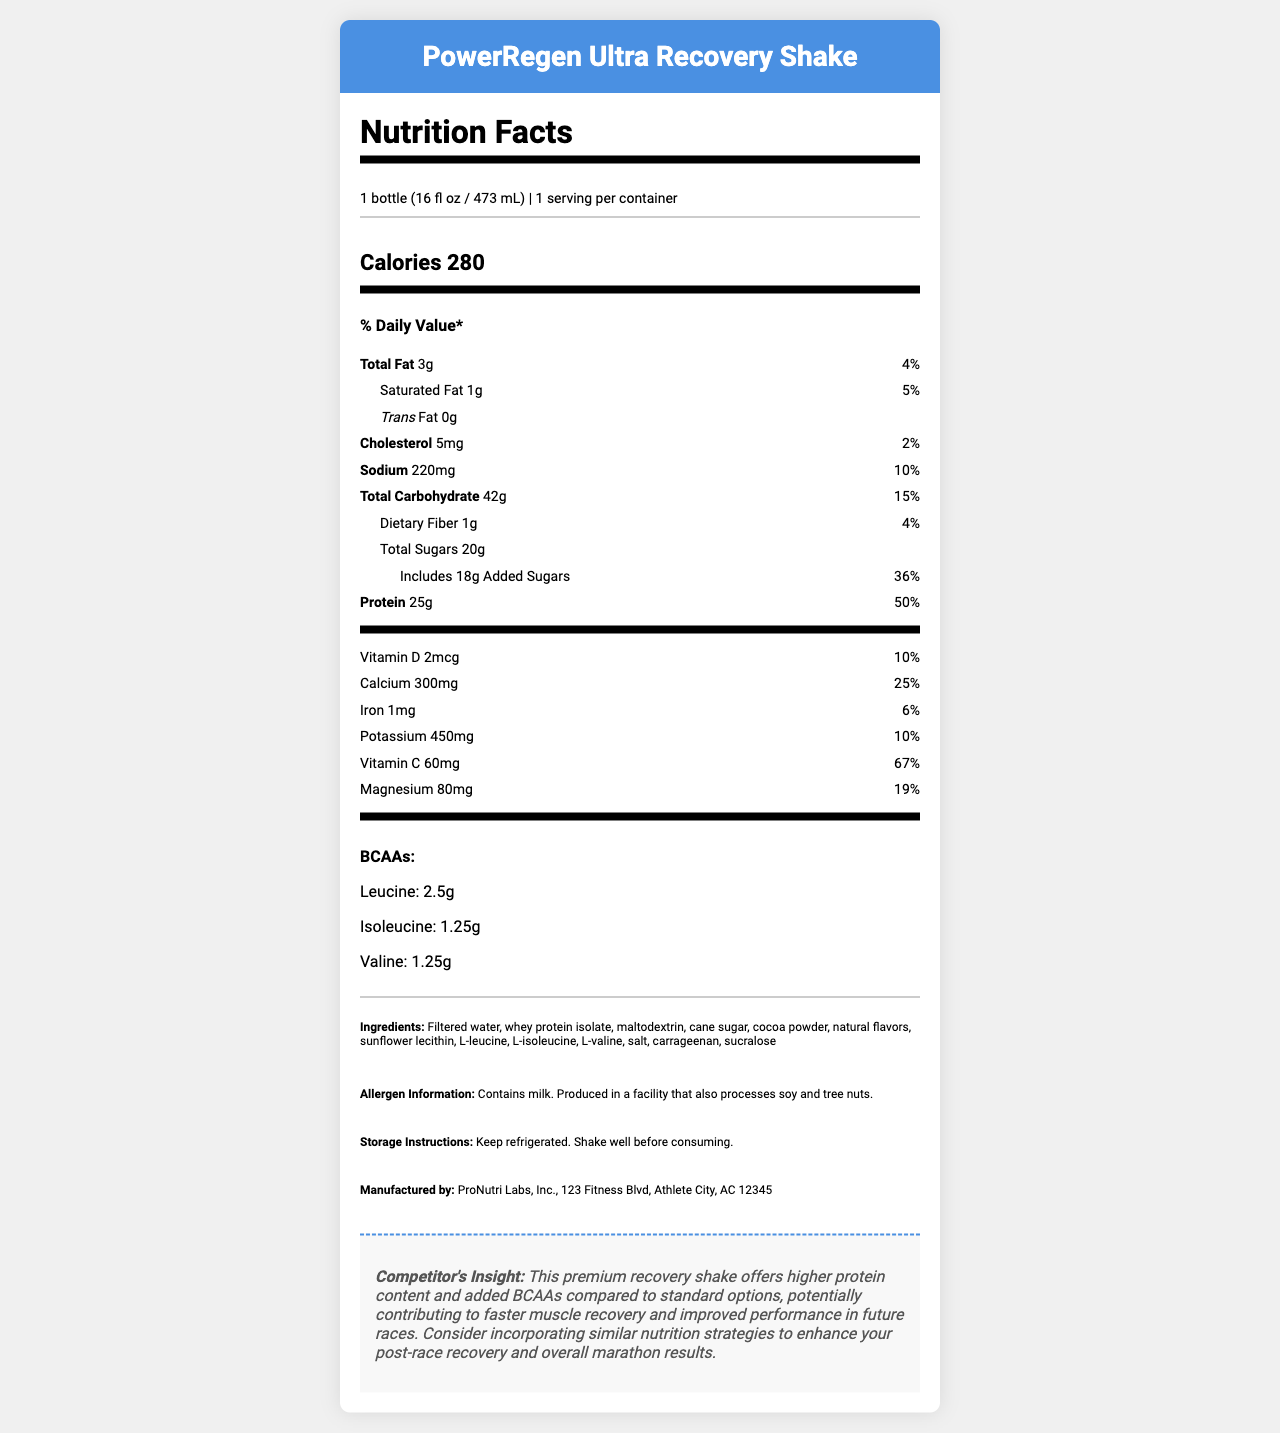what is the name of the product? The name of the product is stated at the top of the document in the header.
Answer: PowerRegen Ultra Recovery Shake what is the serving size of the protein shake? The serving size is listed under the serving information as "1 bottle (16 fl oz / 473 mL)".
Answer: 1 bottle (16 fl oz / 473 mL) how many calories are in one serving? The calorie content per serving is displayed prominently in the calorie information section as "Calories 280".
Answer: 280 calories what percentage of the daily value does the protein in this shake fulfill? The document specifies that the protein content of the shake provides 50% of the daily value.
Answer: 50% how much vitamin C does one serving contain? The vitamin content section lists the amount of vitamin C as 60mg.
Answer: 60mg what is the total carbohydrate content per serving? The total carbohydrate amount is displayed in the daily value section as "42g".
Answer: 42g how many grams of added sugars are in the shake? The document states "Includes 18g Added Sugars" and provides the daily value percentage as well.
Answer: 18g which of the following ingredients is not listed? A. Whey protein isolate B. Cocoa powder C. Soy protein isolate D. Cane sugar The ingredient list in the document does not include soy protein isolate, but it does contain whey protein isolate, cocoa powder, and cane sugar.
Answer: C. Soy protein isolate what is the manufacturer's name? A. PowerFitness Labs B. ProNutri Labs, Inc. C. Marathon Nutrition Co. The manufacturer information section lists ProNutri Labs, Inc. as the manufacturer.
Answer: B. ProNutri Labs, Inc. does the product contain any allergens? The allergen information specifies that the product contains milk and is produced in a facility that also processes soy and tree nuts.
Answer: Yes is this product intended to improve muscle recovery for athletes? The competitor insight clearly mentions that the shake is intended to contribute to faster muscle recovery and improved performance in future races.
Answer: Yes describe the main idea of the document. The document is divided into sections detailing the nutritional facts, ingredients, allergens, and additional insights about the product's benefits for athletic recovery.
Answer: The document provides detailed nutritional information about the PowerRegen Ultra Recovery Shake, highlighting its content of calories, macronutrients, vitamins, minerals, and BCAAs. It also lists ingredients, allergen information, storage instructions, and manufacturer details. The competitor insight suggests the shake's potential benefits for muscle recovery and performance improvement for athletes. what is the main benefit of BCAAs in this product? The document lists the amounts of BCAAs but does not elaborate on their specific benefits. The competitor insight mentions recovery but does not detail how BCAAs contribute.
Answer: Not enough information 